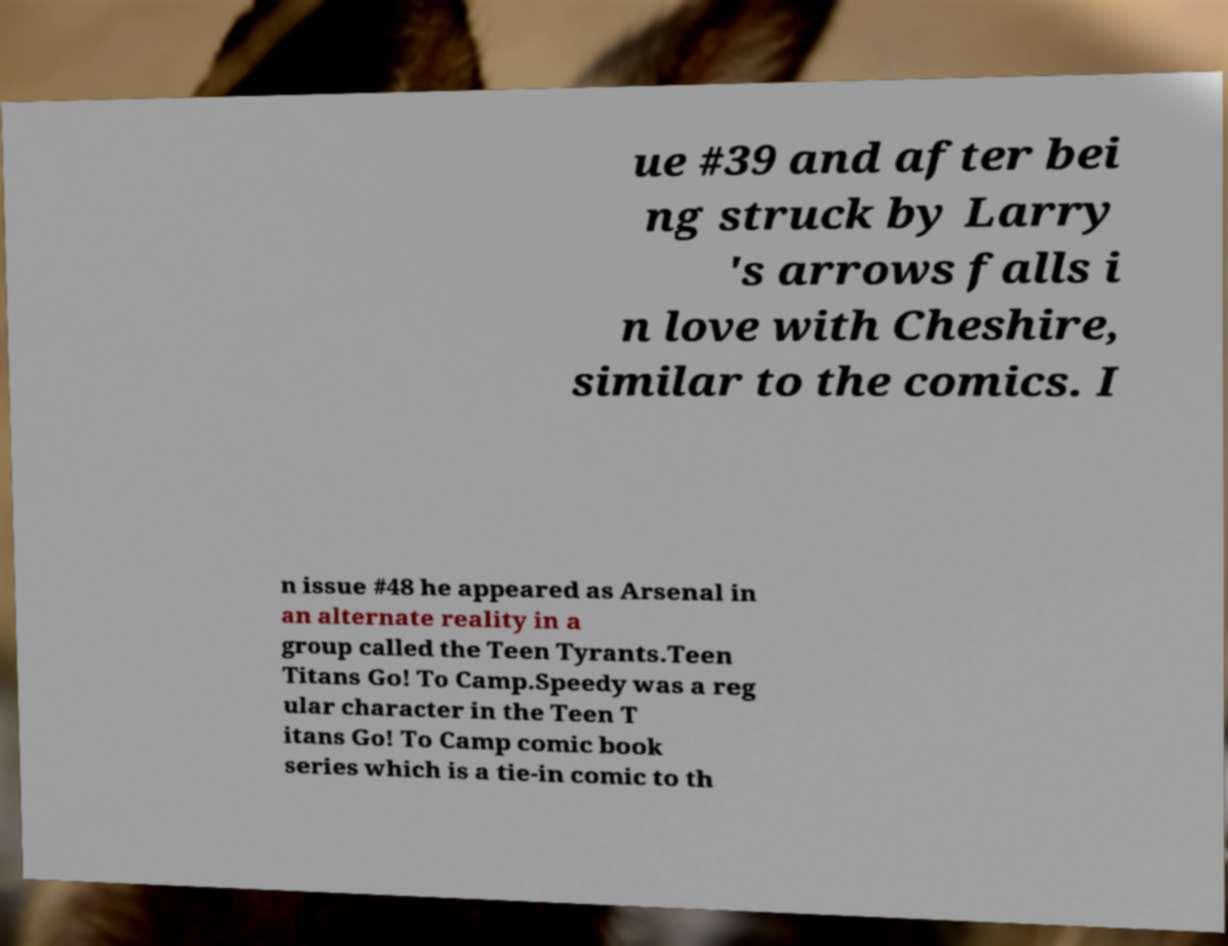There's text embedded in this image that I need extracted. Can you transcribe it verbatim? ue #39 and after bei ng struck by Larry 's arrows falls i n love with Cheshire, similar to the comics. I n issue #48 he appeared as Arsenal in an alternate reality in a group called the Teen Tyrants.Teen Titans Go! To Camp.Speedy was a reg ular character in the Teen T itans Go! To Camp comic book series which is a tie-in comic to th 